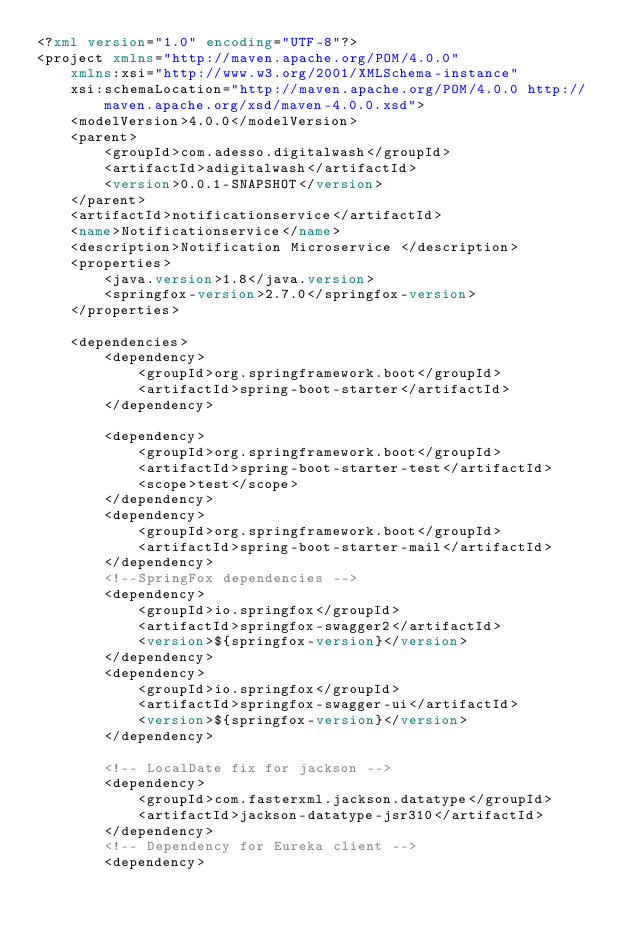<code> <loc_0><loc_0><loc_500><loc_500><_XML_><?xml version="1.0" encoding="UTF-8"?>
<project xmlns="http://maven.apache.org/POM/4.0.0"
	xmlns:xsi="http://www.w3.org/2001/XMLSchema-instance"
	xsi:schemaLocation="http://maven.apache.org/POM/4.0.0 http://maven.apache.org/xsd/maven-4.0.0.xsd">
	<modelVersion>4.0.0</modelVersion>
	<parent>
		<groupId>com.adesso.digitalwash</groupId>
		<artifactId>adigitalwash</artifactId>
		<version>0.0.1-SNAPSHOT</version>
	</parent>
	<artifactId>notificationservice</artifactId>
	<name>Notificationservice</name>
	<description>Notification Microservice </description>
	<properties>
		<java.version>1.8</java.version>
		<springfox-version>2.7.0</springfox-version>
	</properties>

	<dependencies>
		<dependency>
			<groupId>org.springframework.boot</groupId>
			<artifactId>spring-boot-starter</artifactId>
		</dependency>

		<dependency>
			<groupId>org.springframework.boot</groupId>
			<artifactId>spring-boot-starter-test</artifactId>
			<scope>test</scope>
		</dependency>
		<dependency>
			<groupId>org.springframework.boot</groupId>
			<artifactId>spring-boot-starter-mail</artifactId>
		</dependency>
		<!--SpringFox dependencies -->
		<dependency>
			<groupId>io.springfox</groupId>
			<artifactId>springfox-swagger2</artifactId>
			<version>${springfox-version}</version>
		</dependency>
		<dependency>
			<groupId>io.springfox</groupId>
			<artifactId>springfox-swagger-ui</artifactId>
			<version>${springfox-version}</version>
		</dependency>

		<!-- LocalDate fix for jackson -->
		<dependency>
			<groupId>com.fasterxml.jackson.datatype</groupId>
			<artifactId>jackson-datatype-jsr310</artifactId>
		</dependency>
		<!-- Dependency for Eureka client -->
		<dependency></code> 